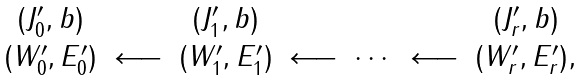<formula> <loc_0><loc_0><loc_500><loc_500>\begin{array} { c c c c c c c c } ( J ^ { \prime } _ { 0 } , b ) & & ( J ^ { \prime } _ { 1 } , b ) & & & & ( J ^ { \prime } _ { r } , b ) \\ ( W ^ { \prime } _ { 0 } , E ^ { \prime } _ { 0 } ) & \longleftarrow & ( W ^ { \prime } _ { 1 } , E ^ { \prime } _ { 1 } ) & \longleftarrow & \cdots & \longleftarrow & ( W ^ { \prime } _ { r } , E ^ { \prime } _ { r } ) , \end{array}</formula> 